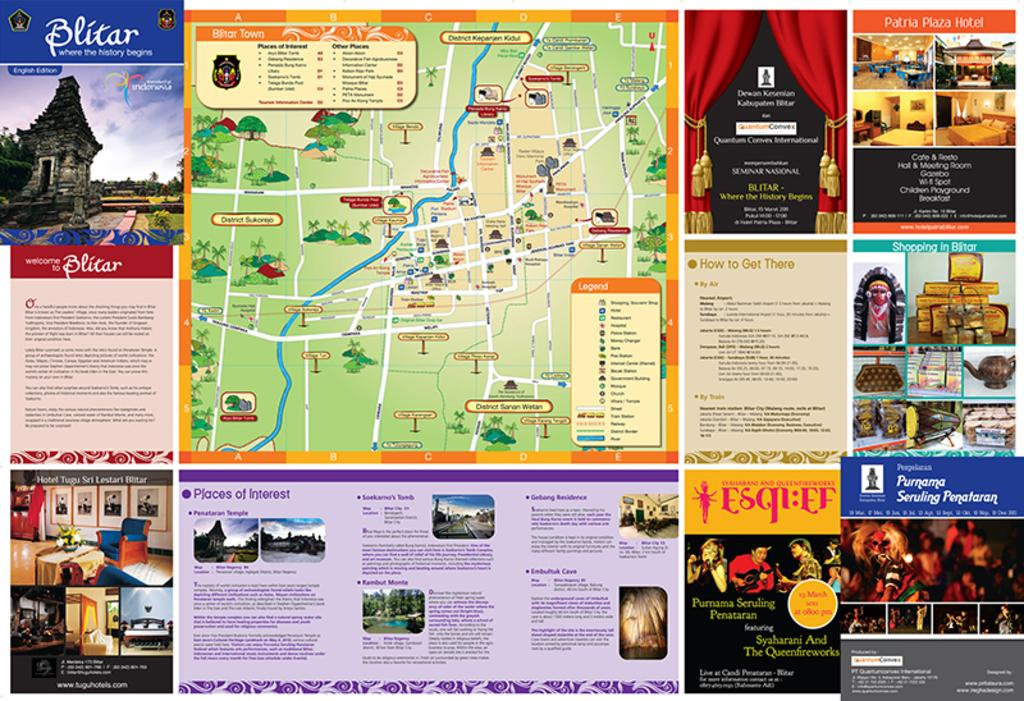<image>
Write a terse but informative summary of the picture. blitar map of indonesia that shows various attractions 